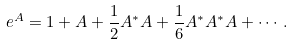<formula> <loc_0><loc_0><loc_500><loc_500>e ^ { A } = 1 + A + \frac { 1 } { 2 } A ^ { * } A + \frac { 1 } { 6 } A ^ { * } A ^ { * } A + \cdots .</formula> 